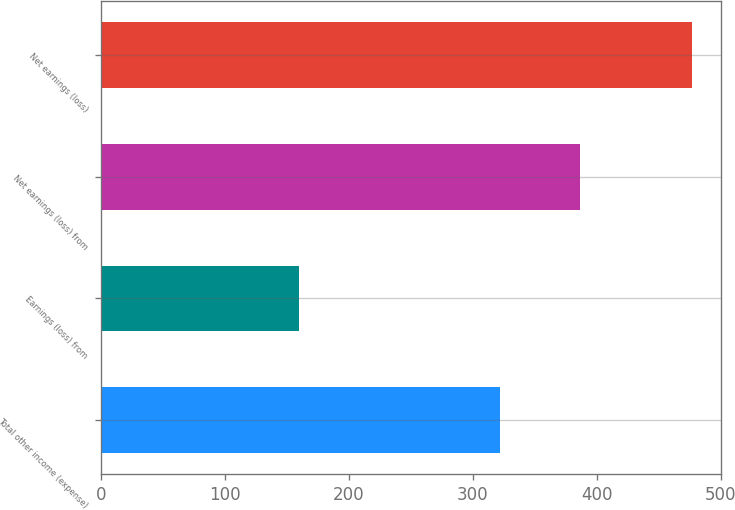<chart> <loc_0><loc_0><loc_500><loc_500><bar_chart><fcel>Total other income (expense)<fcel>Earnings (loss) from<fcel>Net earnings (loss) from<fcel>Net earnings (loss)<nl><fcel>321.9<fcel>159.4<fcel>386.28<fcel>476.6<nl></chart> 